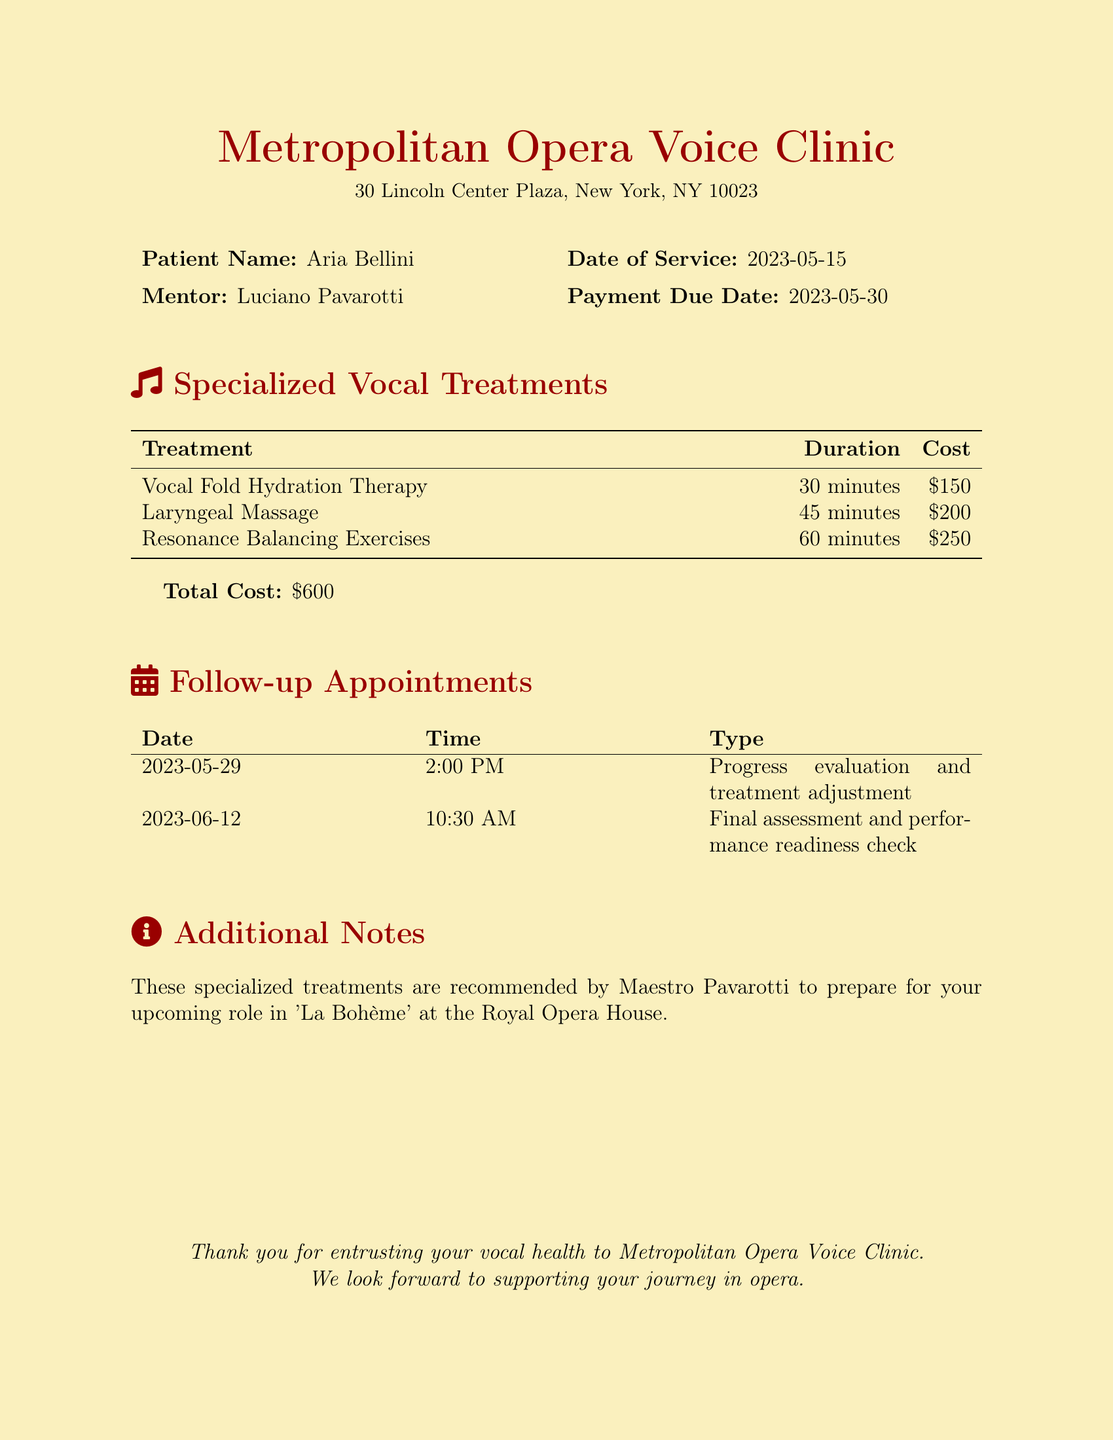What is the patient's name? The patient's name is clearly stated at the top of the document.
Answer: Aria Bellini Who is the mentor? The mentor is mentioned alongside the patient's name, indicating who has recommended the treatments.
Answer: Luciano Pavarotti What is the date of service? The date of service is specified in the document.
Answer: 2023-05-15 What is the total cost of the treatments? The total cost is calculated and presented at the end of the treatment descriptions.
Answer: $600 How long is the Vocal Fold Hydration Therapy session? The duration for each treatment is listed in the table of treatments.
Answer: 30 minutes What is the type of the first follow-up appointment? The type of each follow-up appointment is specified in the table of follow-up appointments.
Answer: Progress evaluation and treatment adjustment When is the final assessment appointment scheduled? The date and time of the final assessment is provided in the follow-up appointments section.
Answer: 2023-06-12 at 10:30 AM What specialized treatment was recommended for the role in ‘La Bohème’? The additional notes section mentions the reason for the specialized treatments.
Answer: Prepare for your upcoming role in 'La Bohème' 